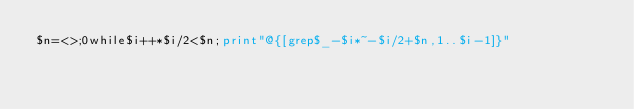Convert code to text. <code><loc_0><loc_0><loc_500><loc_500><_Perl_>$n=<>;0while$i++*$i/2<$n;print"@{[grep$_-$i*~-$i/2+$n,1..$i-1]}"</code> 